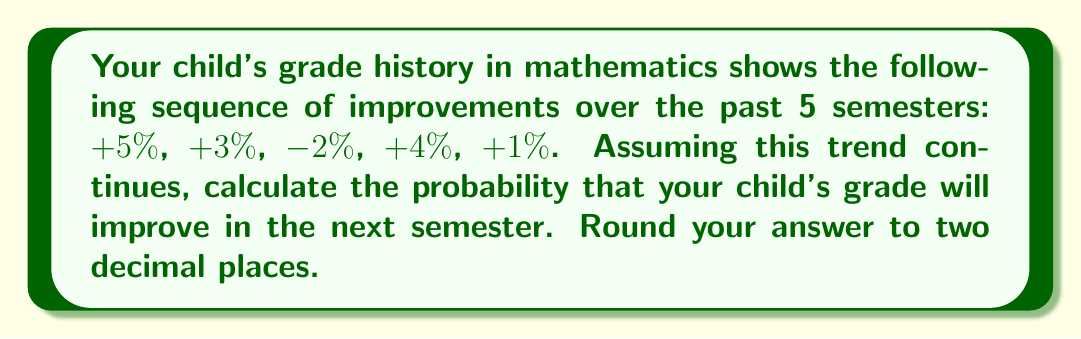Provide a solution to this math problem. Let's approach this step-by-step:

1) First, we need to count the number of improvements in the given data:
   +5%, +3%, -2%, +4%, +1%
   There are 4 improvements out of 5 semesters.

2) In statistical mechanics, we often use the concept of relative frequency to estimate probability. The probability of an event is approximated by:

   $$P(\text{event}) = \frac{\text{number of favorable outcomes}}{\text{total number of trials}}$$

3) In this case:
   - Number of favorable outcomes (improvements): 4
   - Total number of trials (semesters): 5

4) Plugging these values into our formula:

   $$P(\text{improvement}) = \frac{4}{5} = 0.8$$

5) Converting to a percentage and rounding to two decimal places:
   0.8 * 100 = 80%

Therefore, based on the historical data, there is an 80% probability that your child's grade will improve in the next semester.
Answer: 0.80 